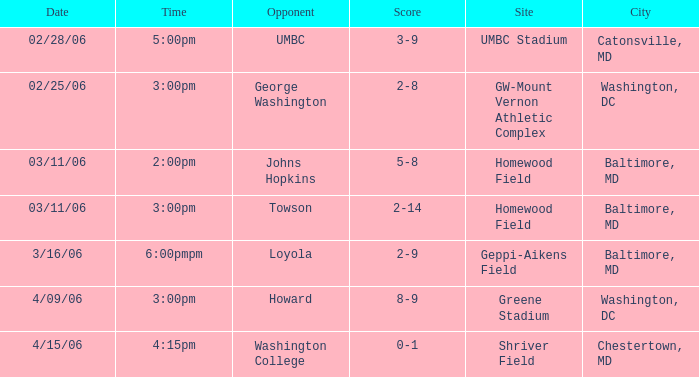Which site has a Score of 0-1? Shriver Field. 